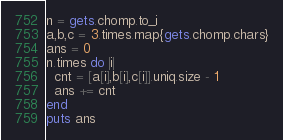Convert code to text. <code><loc_0><loc_0><loc_500><loc_500><_Ruby_>n = gets.chomp.to_i
a,b,c = 3.times.map{gets.chomp.chars}
ans = 0
n.times do |i|
  cnt = [a[i],b[i],c[i]].uniq.size - 1
  ans += cnt
end
puts ans
</code> 